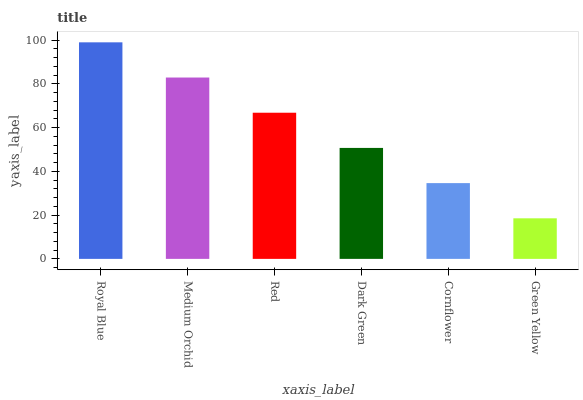Is Green Yellow the minimum?
Answer yes or no. Yes. Is Royal Blue the maximum?
Answer yes or no. Yes. Is Medium Orchid the minimum?
Answer yes or no. No. Is Medium Orchid the maximum?
Answer yes or no. No. Is Royal Blue greater than Medium Orchid?
Answer yes or no. Yes. Is Medium Orchid less than Royal Blue?
Answer yes or no. Yes. Is Medium Orchid greater than Royal Blue?
Answer yes or no. No. Is Royal Blue less than Medium Orchid?
Answer yes or no. No. Is Red the high median?
Answer yes or no. Yes. Is Dark Green the low median?
Answer yes or no. Yes. Is Medium Orchid the high median?
Answer yes or no. No. Is Red the low median?
Answer yes or no. No. 